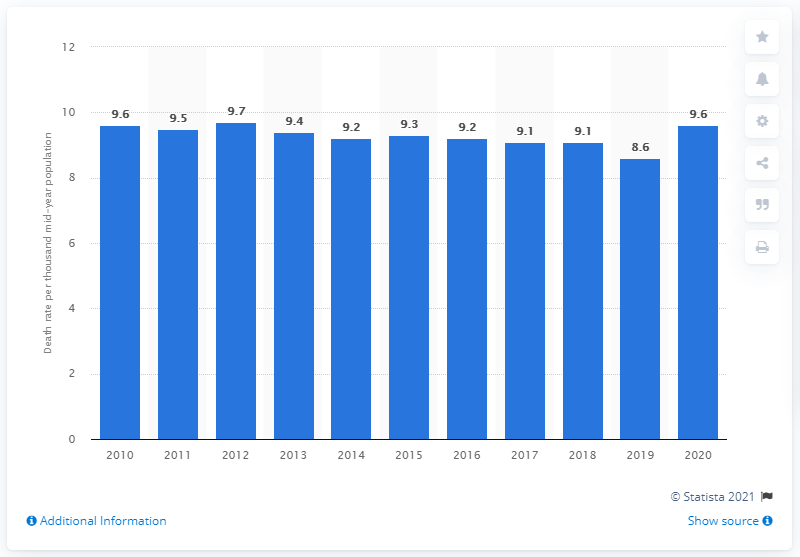Identify some key points in this picture. In 2020, the crude death rate in Sweden was 9.6 per 1,000 people. The crude death rate in Sweden in 2019 was 8.6 deaths per 1,000 population. 